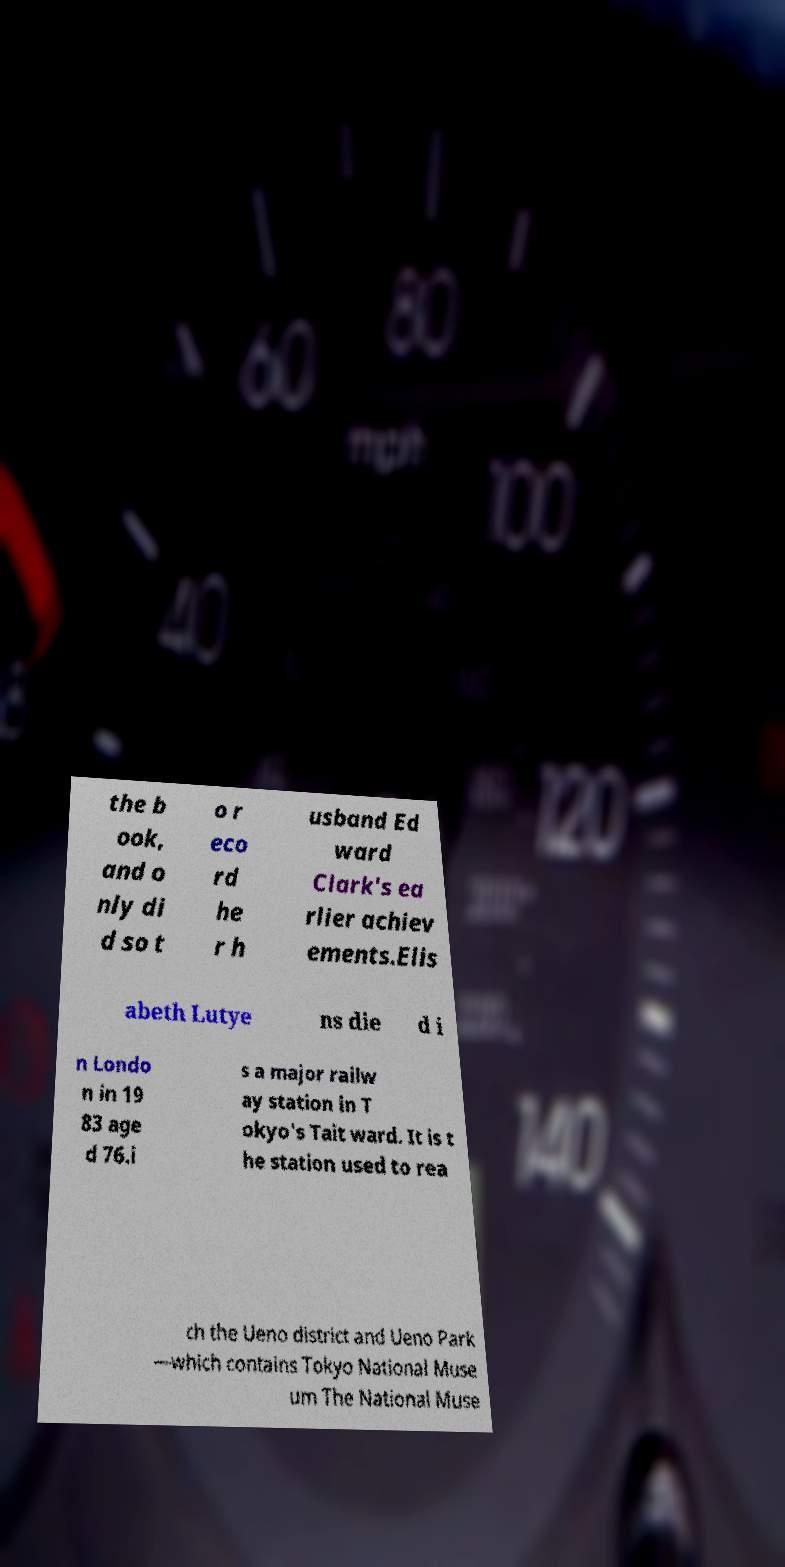Could you extract and type out the text from this image? the b ook, and o nly di d so t o r eco rd he r h usband Ed ward Clark's ea rlier achiev ements.Elis abeth Lutye ns die d i n Londo n in 19 83 age d 76.i s a major railw ay station in T okyo's Tait ward. It is t he station used to rea ch the Ueno district and Ueno Park —which contains Tokyo National Muse um The National Muse 